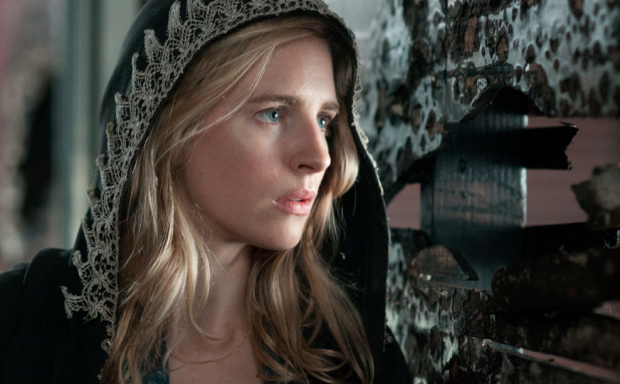Can you imagine a backstory for the character? Absolutely! The woman in the image could be a member of a secretive society, tasked with uncovering hidden truths. She might be a detective or an investigator going through a period of introspection after discovering unsettling information about a case. The peeling posters could represent a fallen era, suggesting she is probing into long-forgotten mysteries, trying to piece together fragments of the past to find answers in the present. How might the setting influence the character's backstory? The setting, with its peeling posters and rough texture, evokes a sense of history and decay, suggesting that the character’s backstory is rooted in uncovering dark secrets or forgotten histories. This backdrop implies a world where the past lingers in the present, affecting the character's actions and motivations. Such a setting could indicate that the character is battling against time to reveal truths that have long been buried. 